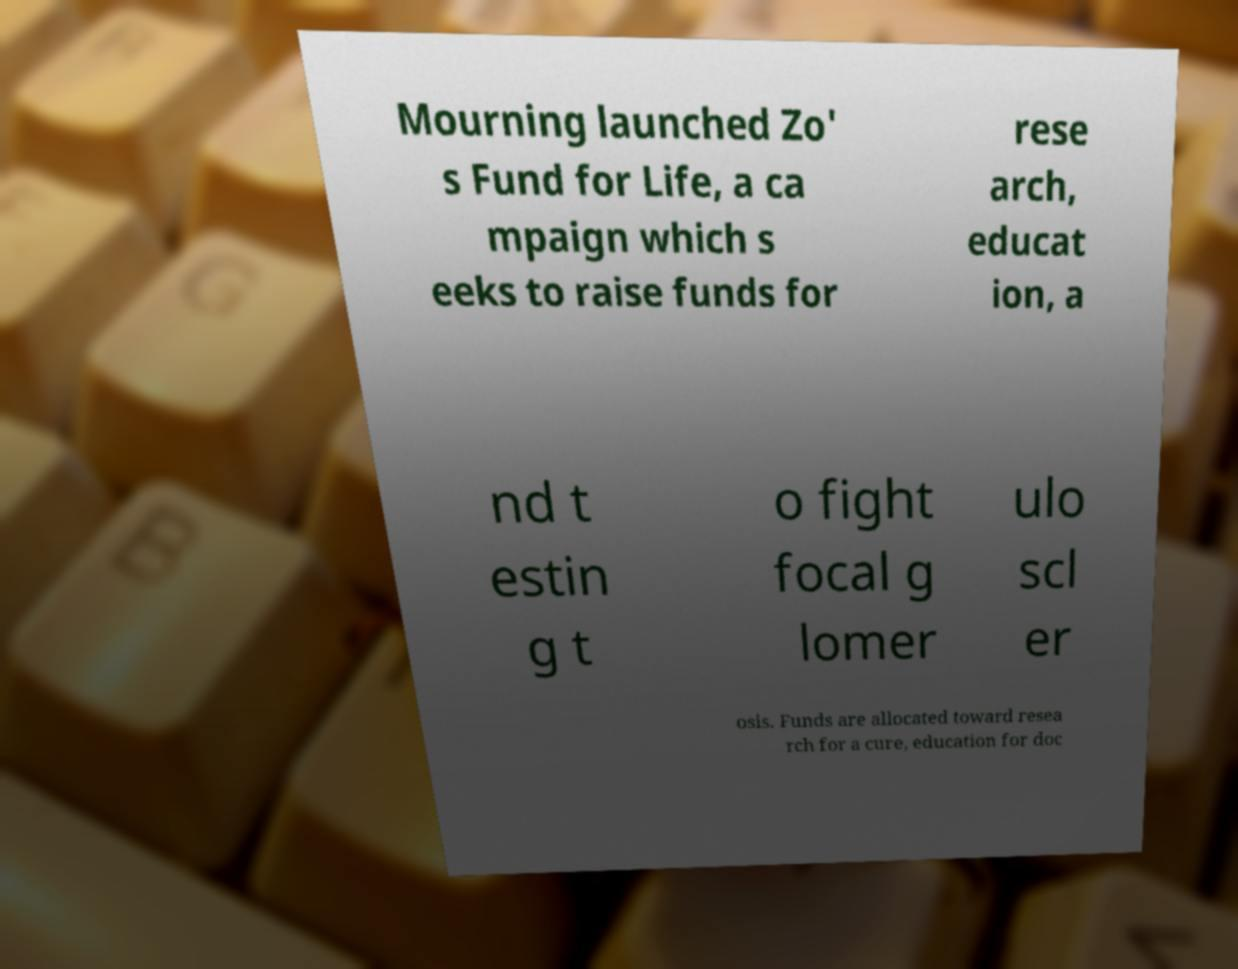What messages or text are displayed in this image? I need them in a readable, typed format. Mourning launched Zo' s Fund for Life, a ca mpaign which s eeks to raise funds for rese arch, educat ion, a nd t estin g t o fight focal g lomer ulo scl er osis. Funds are allocated toward resea rch for a cure, education for doc 